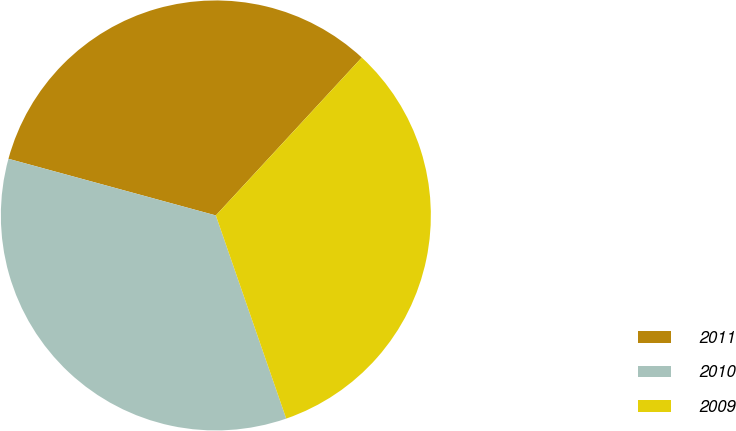Convert chart to OTSL. <chart><loc_0><loc_0><loc_500><loc_500><pie_chart><fcel>2011<fcel>2010<fcel>2009<nl><fcel>32.63%<fcel>34.55%<fcel>32.82%<nl></chart> 